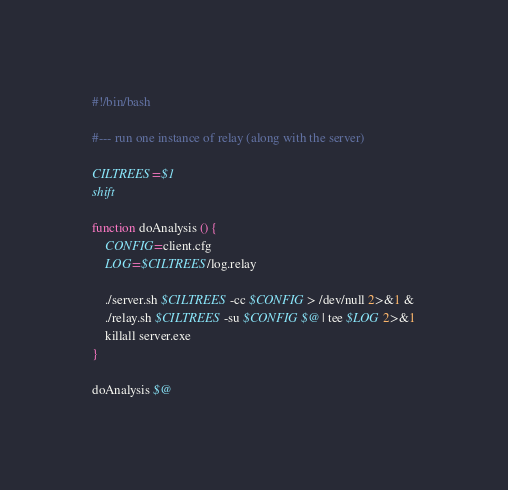<code> <loc_0><loc_0><loc_500><loc_500><_Bash_>#!/bin/bash

#--- run one instance of relay (along with the server)

CILTREES=$1
shift 

function doAnalysis () {
    CONFIG=client.cfg
    LOG=$CILTREES/log.relay

    ./server.sh $CILTREES -cc $CONFIG > /dev/null 2>&1 &
    ./relay.sh $CILTREES -su $CONFIG $@ | tee $LOG 2>&1
    killall server.exe
}

doAnalysis $@
</code> 